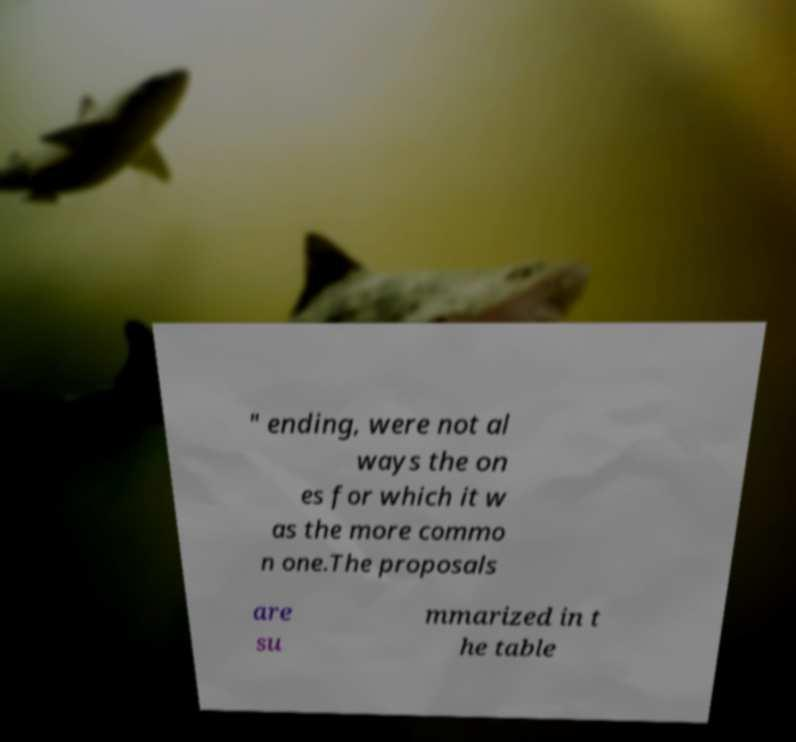I need the written content from this picture converted into text. Can you do that? " ending, were not al ways the on es for which it w as the more commo n one.The proposals are su mmarized in t he table 